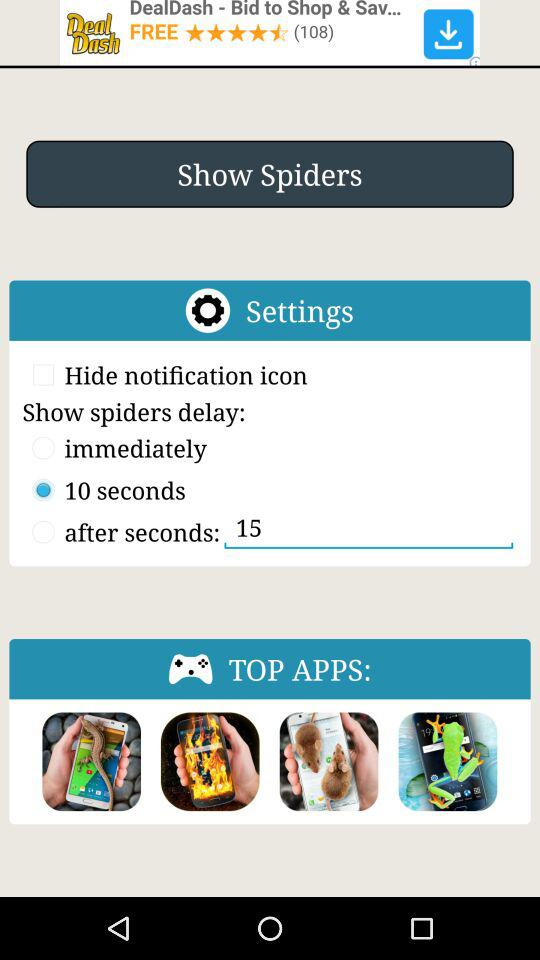What is typed in "after seconds"? In "after seconds", 15 is typed. 